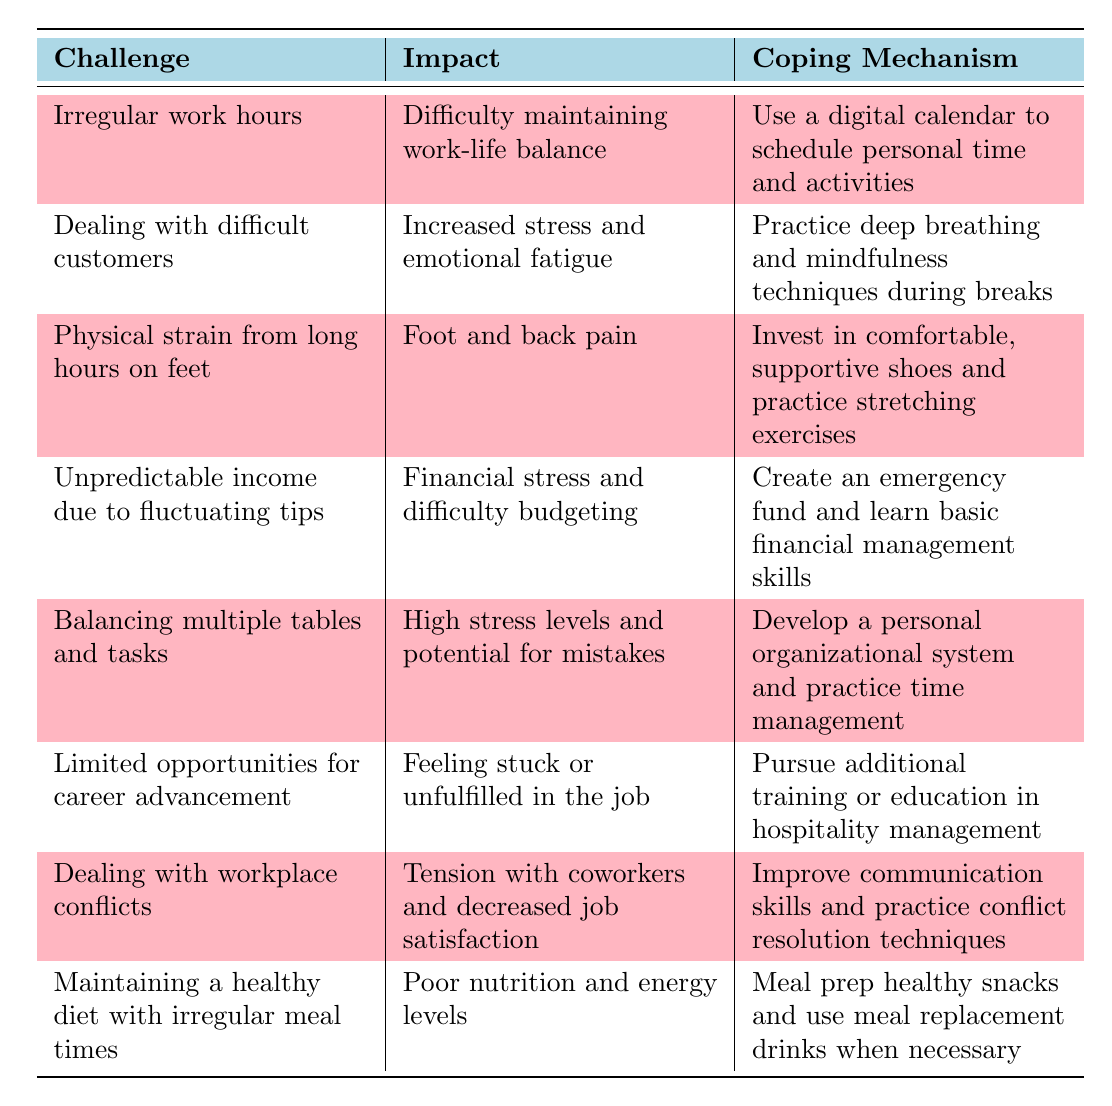What is one of the challenges related to work hours faced by waitstaff? The table lists "Irregular work hours" as one of the challenges in the first row under the "Challenge" column.
Answer: Irregular work hours What impact does dealing with difficult customers have on waitstaff? According to the table, the impact of dealing with difficult customers is "Increased stress and emotional fatigue,” which is stated in the second row of the “Impact” column.
Answer: Increased stress and emotional fatigue How do waitstaff cope with financial stress from unpredictable income? The coping mechanism for unpredictable income is to "Create an emergency fund and learn basic financial management skills," as shown in the fourth row under the "Coping Mechanism" column.
Answer: Create an emergency fund and learn basic financial management skills What is the main physical challenge faced by waitstaff due to long hours on their feet? The main physical challenge highlighted in the table is "Foot and back pain," located in the third row under the "Impact" column.
Answer: Foot and back pain Which coping mechanism is suggested for improving job satisfaction amidst workplace conflicts? The coping mechanism listed for dealing with workplace conflicts is "Improve communication skills and practice conflict resolution techniques," found in the sixth row under "Coping Mechanism."
Answer: Improve communication skills and practice conflict resolution techniques Are there any challenges related to diet mentioned in the table? Yes, the table mentions "Maintaining a healthy diet with irregular meal times" as a challenge in the last row under the "Challenge" column.
Answer: Yes What is the total number of challenges listed in the table? The table contains a total of 8 challenges under the "Challenge" column.
Answer: 8 What is the coping mechanism advised for managing multiple tables and tasks? The table states that the coping mechanism is to "Develop a personal organizational system and practice time management," which can be found in the fifth row under "Coping Mechanism."
Answer: Develop a personal organizational system and practice time management Comparing the impacts of “Dealing with difficult customers” and “Limited opportunities for career advancement,” which one reflects greater emotional repercussions? "Dealing with difficult customers" has an impact of increased stress and emotional fatigue, while "Limited opportunities for career advancement" indicates feeling stuck or unfulfilled. The former has a more direct emotional impact.
Answer: Dealing with difficult customers What percentage of the total challenges relate to physical strains or health? Out of the 8 total challenges, 2 are related to physical strains (long hours on feet and maintaining a healthy diet). Therefore, the percentage is (2/8) * 100 = 25%.
Answer: 25% 